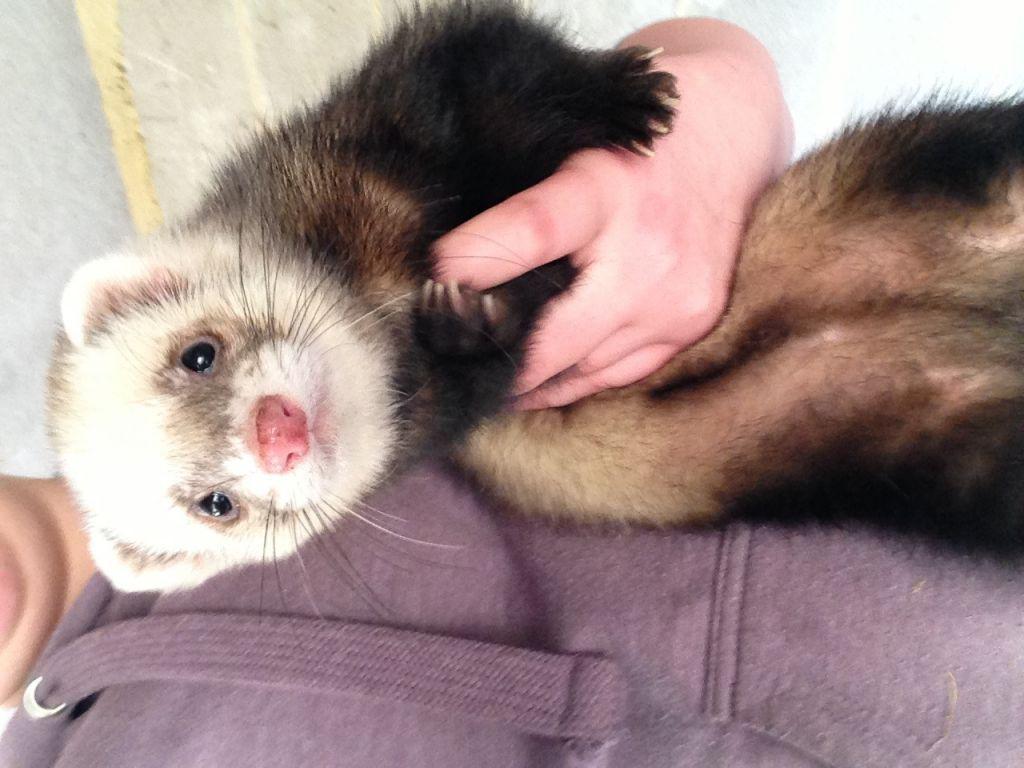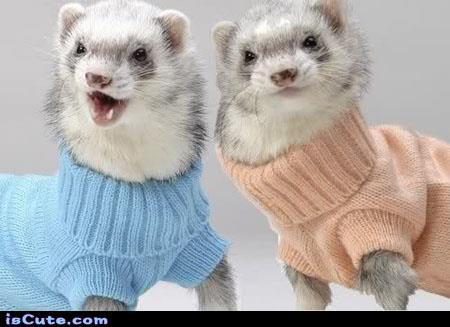The first image is the image on the left, the second image is the image on the right. Assess this claim about the two images: "Two ferrets with the same fur color pattern are wearing clothes.". Correct or not? Answer yes or no. Yes. The first image is the image on the left, the second image is the image on the right. Evaluate the accuracy of this statement regarding the images: "Each image contains two ferrets, and one image shows hands holding up unclothed ferrets.". Is it true? Answer yes or no. No. 